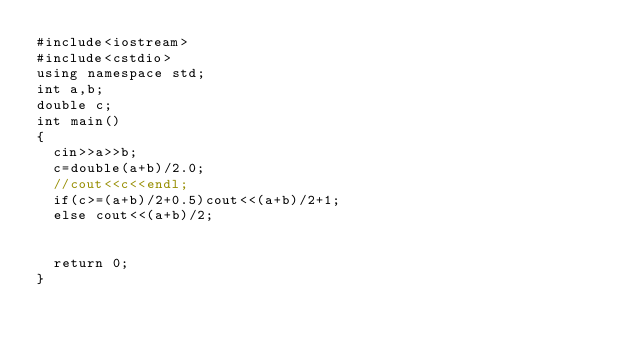Convert code to text. <code><loc_0><loc_0><loc_500><loc_500><_C++_>#include<iostream>
#include<cstdio>
using namespace std;
int a,b;
double c;
int main()
{
	cin>>a>>b;
	c=double(a+b)/2.0;
	//cout<<c<<endl;
	if(c>=(a+b)/2+0.5)cout<<(a+b)/2+1;
	else cout<<(a+b)/2;
	
	
	return 0;
} </code> 